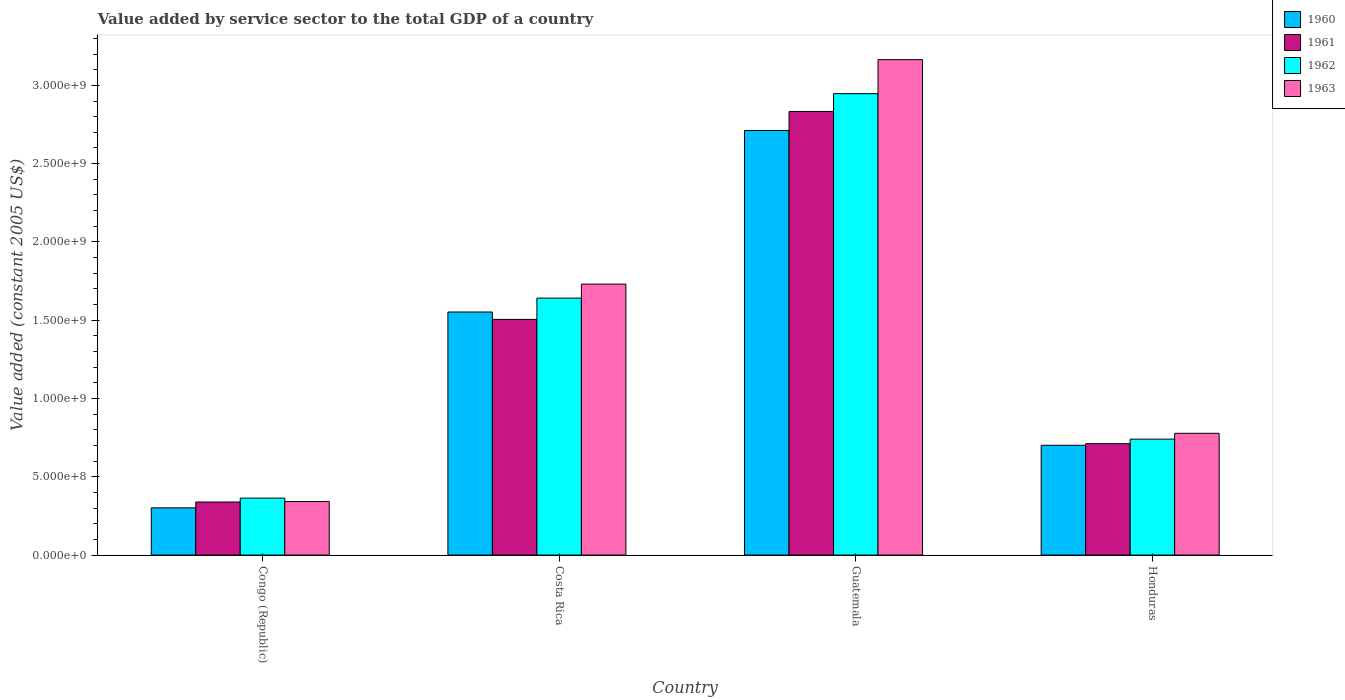Are the number of bars per tick equal to the number of legend labels?
Provide a succinct answer. Yes. Are the number of bars on each tick of the X-axis equal?
Keep it short and to the point. Yes. How many bars are there on the 4th tick from the left?
Give a very brief answer. 4. What is the value added by service sector in 1962 in Honduras?
Your answer should be compact. 7.41e+08. Across all countries, what is the maximum value added by service sector in 1962?
Keep it short and to the point. 2.95e+09. Across all countries, what is the minimum value added by service sector in 1961?
Your answer should be very brief. 3.39e+08. In which country was the value added by service sector in 1961 maximum?
Keep it short and to the point. Guatemala. In which country was the value added by service sector in 1963 minimum?
Keep it short and to the point. Congo (Republic). What is the total value added by service sector in 1963 in the graph?
Your answer should be compact. 6.01e+09. What is the difference between the value added by service sector in 1960 in Congo (Republic) and that in Honduras?
Your answer should be very brief. -4.00e+08. What is the difference between the value added by service sector in 1961 in Honduras and the value added by service sector in 1960 in Congo (Republic)?
Your answer should be compact. 4.10e+08. What is the average value added by service sector in 1961 per country?
Your response must be concise. 1.35e+09. What is the difference between the value added by service sector of/in 1961 and value added by service sector of/in 1962 in Costa Rica?
Make the answer very short. -1.36e+08. What is the ratio of the value added by service sector in 1960 in Congo (Republic) to that in Honduras?
Your answer should be compact. 0.43. What is the difference between the highest and the second highest value added by service sector in 1962?
Your response must be concise. -1.31e+09. What is the difference between the highest and the lowest value added by service sector in 1962?
Offer a terse response. 2.58e+09. In how many countries, is the value added by service sector in 1963 greater than the average value added by service sector in 1963 taken over all countries?
Ensure brevity in your answer.  2. Is the sum of the value added by service sector in 1960 in Costa Rica and Guatemala greater than the maximum value added by service sector in 1963 across all countries?
Give a very brief answer. Yes. Is it the case that in every country, the sum of the value added by service sector in 1960 and value added by service sector in 1963 is greater than the sum of value added by service sector in 1961 and value added by service sector in 1962?
Make the answer very short. No. How many bars are there?
Provide a short and direct response. 16. What is the difference between two consecutive major ticks on the Y-axis?
Your response must be concise. 5.00e+08. Are the values on the major ticks of Y-axis written in scientific E-notation?
Ensure brevity in your answer.  Yes. Does the graph contain grids?
Ensure brevity in your answer.  No. What is the title of the graph?
Your answer should be very brief. Value added by service sector to the total GDP of a country. What is the label or title of the X-axis?
Your response must be concise. Country. What is the label or title of the Y-axis?
Offer a terse response. Value added (constant 2005 US$). What is the Value added (constant 2005 US$) of 1960 in Congo (Republic)?
Provide a short and direct response. 3.02e+08. What is the Value added (constant 2005 US$) of 1961 in Congo (Republic)?
Ensure brevity in your answer.  3.39e+08. What is the Value added (constant 2005 US$) of 1962 in Congo (Republic)?
Your answer should be very brief. 3.64e+08. What is the Value added (constant 2005 US$) in 1963 in Congo (Republic)?
Your response must be concise. 3.42e+08. What is the Value added (constant 2005 US$) of 1960 in Costa Rica?
Provide a short and direct response. 1.55e+09. What is the Value added (constant 2005 US$) in 1961 in Costa Rica?
Offer a terse response. 1.51e+09. What is the Value added (constant 2005 US$) in 1962 in Costa Rica?
Keep it short and to the point. 1.64e+09. What is the Value added (constant 2005 US$) of 1963 in Costa Rica?
Keep it short and to the point. 1.73e+09. What is the Value added (constant 2005 US$) of 1960 in Guatemala?
Your response must be concise. 2.71e+09. What is the Value added (constant 2005 US$) in 1961 in Guatemala?
Your answer should be very brief. 2.83e+09. What is the Value added (constant 2005 US$) of 1962 in Guatemala?
Make the answer very short. 2.95e+09. What is the Value added (constant 2005 US$) of 1963 in Guatemala?
Ensure brevity in your answer.  3.16e+09. What is the Value added (constant 2005 US$) in 1960 in Honduras?
Your answer should be compact. 7.01e+08. What is the Value added (constant 2005 US$) of 1961 in Honduras?
Your response must be concise. 7.12e+08. What is the Value added (constant 2005 US$) in 1962 in Honduras?
Your response must be concise. 7.41e+08. What is the Value added (constant 2005 US$) of 1963 in Honduras?
Offer a very short reply. 7.78e+08. Across all countries, what is the maximum Value added (constant 2005 US$) of 1960?
Your response must be concise. 2.71e+09. Across all countries, what is the maximum Value added (constant 2005 US$) of 1961?
Provide a succinct answer. 2.83e+09. Across all countries, what is the maximum Value added (constant 2005 US$) of 1962?
Your answer should be compact. 2.95e+09. Across all countries, what is the maximum Value added (constant 2005 US$) in 1963?
Your answer should be compact. 3.16e+09. Across all countries, what is the minimum Value added (constant 2005 US$) in 1960?
Keep it short and to the point. 3.02e+08. Across all countries, what is the minimum Value added (constant 2005 US$) in 1961?
Keep it short and to the point. 3.39e+08. Across all countries, what is the minimum Value added (constant 2005 US$) of 1962?
Provide a succinct answer. 3.64e+08. Across all countries, what is the minimum Value added (constant 2005 US$) in 1963?
Your answer should be compact. 3.42e+08. What is the total Value added (constant 2005 US$) of 1960 in the graph?
Offer a very short reply. 5.27e+09. What is the total Value added (constant 2005 US$) in 1961 in the graph?
Keep it short and to the point. 5.39e+09. What is the total Value added (constant 2005 US$) of 1962 in the graph?
Make the answer very short. 5.69e+09. What is the total Value added (constant 2005 US$) of 1963 in the graph?
Give a very brief answer. 6.01e+09. What is the difference between the Value added (constant 2005 US$) of 1960 in Congo (Republic) and that in Costa Rica?
Your answer should be very brief. -1.25e+09. What is the difference between the Value added (constant 2005 US$) in 1961 in Congo (Republic) and that in Costa Rica?
Keep it short and to the point. -1.17e+09. What is the difference between the Value added (constant 2005 US$) of 1962 in Congo (Republic) and that in Costa Rica?
Ensure brevity in your answer.  -1.28e+09. What is the difference between the Value added (constant 2005 US$) in 1963 in Congo (Republic) and that in Costa Rica?
Keep it short and to the point. -1.39e+09. What is the difference between the Value added (constant 2005 US$) of 1960 in Congo (Republic) and that in Guatemala?
Offer a terse response. -2.41e+09. What is the difference between the Value added (constant 2005 US$) of 1961 in Congo (Republic) and that in Guatemala?
Give a very brief answer. -2.49e+09. What is the difference between the Value added (constant 2005 US$) of 1962 in Congo (Republic) and that in Guatemala?
Offer a very short reply. -2.58e+09. What is the difference between the Value added (constant 2005 US$) of 1963 in Congo (Republic) and that in Guatemala?
Make the answer very short. -2.82e+09. What is the difference between the Value added (constant 2005 US$) in 1960 in Congo (Republic) and that in Honduras?
Keep it short and to the point. -4.00e+08. What is the difference between the Value added (constant 2005 US$) in 1961 in Congo (Republic) and that in Honduras?
Make the answer very short. -3.73e+08. What is the difference between the Value added (constant 2005 US$) of 1962 in Congo (Republic) and that in Honduras?
Offer a terse response. -3.77e+08. What is the difference between the Value added (constant 2005 US$) of 1963 in Congo (Republic) and that in Honduras?
Give a very brief answer. -4.36e+08. What is the difference between the Value added (constant 2005 US$) of 1960 in Costa Rica and that in Guatemala?
Give a very brief answer. -1.16e+09. What is the difference between the Value added (constant 2005 US$) of 1961 in Costa Rica and that in Guatemala?
Make the answer very short. -1.33e+09. What is the difference between the Value added (constant 2005 US$) of 1962 in Costa Rica and that in Guatemala?
Offer a terse response. -1.31e+09. What is the difference between the Value added (constant 2005 US$) in 1963 in Costa Rica and that in Guatemala?
Ensure brevity in your answer.  -1.43e+09. What is the difference between the Value added (constant 2005 US$) of 1960 in Costa Rica and that in Honduras?
Give a very brief answer. 8.51e+08. What is the difference between the Value added (constant 2005 US$) of 1961 in Costa Rica and that in Honduras?
Provide a succinct answer. 7.94e+08. What is the difference between the Value added (constant 2005 US$) of 1962 in Costa Rica and that in Honduras?
Your answer should be compact. 9.01e+08. What is the difference between the Value added (constant 2005 US$) in 1963 in Costa Rica and that in Honduras?
Offer a very short reply. 9.53e+08. What is the difference between the Value added (constant 2005 US$) of 1960 in Guatemala and that in Honduras?
Your answer should be very brief. 2.01e+09. What is the difference between the Value added (constant 2005 US$) in 1961 in Guatemala and that in Honduras?
Make the answer very short. 2.12e+09. What is the difference between the Value added (constant 2005 US$) of 1962 in Guatemala and that in Honduras?
Provide a succinct answer. 2.21e+09. What is the difference between the Value added (constant 2005 US$) of 1963 in Guatemala and that in Honduras?
Your answer should be very brief. 2.39e+09. What is the difference between the Value added (constant 2005 US$) of 1960 in Congo (Republic) and the Value added (constant 2005 US$) of 1961 in Costa Rica?
Your answer should be compact. -1.20e+09. What is the difference between the Value added (constant 2005 US$) in 1960 in Congo (Republic) and the Value added (constant 2005 US$) in 1962 in Costa Rica?
Your response must be concise. -1.34e+09. What is the difference between the Value added (constant 2005 US$) in 1960 in Congo (Republic) and the Value added (constant 2005 US$) in 1963 in Costa Rica?
Offer a terse response. -1.43e+09. What is the difference between the Value added (constant 2005 US$) in 1961 in Congo (Republic) and the Value added (constant 2005 US$) in 1962 in Costa Rica?
Give a very brief answer. -1.30e+09. What is the difference between the Value added (constant 2005 US$) of 1961 in Congo (Republic) and the Value added (constant 2005 US$) of 1963 in Costa Rica?
Give a very brief answer. -1.39e+09. What is the difference between the Value added (constant 2005 US$) in 1962 in Congo (Republic) and the Value added (constant 2005 US$) in 1963 in Costa Rica?
Your response must be concise. -1.37e+09. What is the difference between the Value added (constant 2005 US$) of 1960 in Congo (Republic) and the Value added (constant 2005 US$) of 1961 in Guatemala?
Offer a terse response. -2.53e+09. What is the difference between the Value added (constant 2005 US$) in 1960 in Congo (Republic) and the Value added (constant 2005 US$) in 1962 in Guatemala?
Your answer should be compact. -2.65e+09. What is the difference between the Value added (constant 2005 US$) in 1960 in Congo (Republic) and the Value added (constant 2005 US$) in 1963 in Guatemala?
Your response must be concise. -2.86e+09. What is the difference between the Value added (constant 2005 US$) of 1961 in Congo (Republic) and the Value added (constant 2005 US$) of 1962 in Guatemala?
Offer a terse response. -2.61e+09. What is the difference between the Value added (constant 2005 US$) of 1961 in Congo (Republic) and the Value added (constant 2005 US$) of 1963 in Guatemala?
Ensure brevity in your answer.  -2.83e+09. What is the difference between the Value added (constant 2005 US$) in 1962 in Congo (Republic) and the Value added (constant 2005 US$) in 1963 in Guatemala?
Provide a succinct answer. -2.80e+09. What is the difference between the Value added (constant 2005 US$) of 1960 in Congo (Republic) and the Value added (constant 2005 US$) of 1961 in Honduras?
Provide a succinct answer. -4.10e+08. What is the difference between the Value added (constant 2005 US$) in 1960 in Congo (Republic) and the Value added (constant 2005 US$) in 1962 in Honduras?
Offer a very short reply. -4.39e+08. What is the difference between the Value added (constant 2005 US$) of 1960 in Congo (Republic) and the Value added (constant 2005 US$) of 1963 in Honduras?
Give a very brief answer. -4.76e+08. What is the difference between the Value added (constant 2005 US$) in 1961 in Congo (Republic) and the Value added (constant 2005 US$) in 1962 in Honduras?
Offer a very short reply. -4.02e+08. What is the difference between the Value added (constant 2005 US$) in 1961 in Congo (Republic) and the Value added (constant 2005 US$) in 1963 in Honduras?
Your answer should be compact. -4.39e+08. What is the difference between the Value added (constant 2005 US$) in 1962 in Congo (Republic) and the Value added (constant 2005 US$) in 1963 in Honduras?
Provide a succinct answer. -4.14e+08. What is the difference between the Value added (constant 2005 US$) in 1960 in Costa Rica and the Value added (constant 2005 US$) in 1961 in Guatemala?
Your answer should be compact. -1.28e+09. What is the difference between the Value added (constant 2005 US$) in 1960 in Costa Rica and the Value added (constant 2005 US$) in 1962 in Guatemala?
Provide a succinct answer. -1.39e+09. What is the difference between the Value added (constant 2005 US$) in 1960 in Costa Rica and the Value added (constant 2005 US$) in 1963 in Guatemala?
Keep it short and to the point. -1.61e+09. What is the difference between the Value added (constant 2005 US$) in 1961 in Costa Rica and the Value added (constant 2005 US$) in 1962 in Guatemala?
Provide a succinct answer. -1.44e+09. What is the difference between the Value added (constant 2005 US$) of 1961 in Costa Rica and the Value added (constant 2005 US$) of 1963 in Guatemala?
Offer a very short reply. -1.66e+09. What is the difference between the Value added (constant 2005 US$) in 1962 in Costa Rica and the Value added (constant 2005 US$) in 1963 in Guatemala?
Make the answer very short. -1.52e+09. What is the difference between the Value added (constant 2005 US$) in 1960 in Costa Rica and the Value added (constant 2005 US$) in 1961 in Honduras?
Offer a terse response. 8.41e+08. What is the difference between the Value added (constant 2005 US$) of 1960 in Costa Rica and the Value added (constant 2005 US$) of 1962 in Honduras?
Give a very brief answer. 8.12e+08. What is the difference between the Value added (constant 2005 US$) in 1960 in Costa Rica and the Value added (constant 2005 US$) in 1963 in Honduras?
Your answer should be compact. 7.75e+08. What is the difference between the Value added (constant 2005 US$) of 1961 in Costa Rica and the Value added (constant 2005 US$) of 1962 in Honduras?
Your response must be concise. 7.65e+08. What is the difference between the Value added (constant 2005 US$) in 1961 in Costa Rica and the Value added (constant 2005 US$) in 1963 in Honduras?
Keep it short and to the point. 7.28e+08. What is the difference between the Value added (constant 2005 US$) of 1962 in Costa Rica and the Value added (constant 2005 US$) of 1963 in Honduras?
Give a very brief answer. 8.63e+08. What is the difference between the Value added (constant 2005 US$) of 1960 in Guatemala and the Value added (constant 2005 US$) of 1961 in Honduras?
Make the answer very short. 2.00e+09. What is the difference between the Value added (constant 2005 US$) of 1960 in Guatemala and the Value added (constant 2005 US$) of 1962 in Honduras?
Provide a succinct answer. 1.97e+09. What is the difference between the Value added (constant 2005 US$) in 1960 in Guatemala and the Value added (constant 2005 US$) in 1963 in Honduras?
Make the answer very short. 1.93e+09. What is the difference between the Value added (constant 2005 US$) in 1961 in Guatemala and the Value added (constant 2005 US$) in 1962 in Honduras?
Your response must be concise. 2.09e+09. What is the difference between the Value added (constant 2005 US$) of 1961 in Guatemala and the Value added (constant 2005 US$) of 1963 in Honduras?
Provide a short and direct response. 2.06e+09. What is the difference between the Value added (constant 2005 US$) of 1962 in Guatemala and the Value added (constant 2005 US$) of 1963 in Honduras?
Your response must be concise. 2.17e+09. What is the average Value added (constant 2005 US$) in 1960 per country?
Provide a short and direct response. 1.32e+09. What is the average Value added (constant 2005 US$) in 1961 per country?
Your answer should be compact. 1.35e+09. What is the average Value added (constant 2005 US$) of 1962 per country?
Offer a very short reply. 1.42e+09. What is the average Value added (constant 2005 US$) in 1963 per country?
Make the answer very short. 1.50e+09. What is the difference between the Value added (constant 2005 US$) in 1960 and Value added (constant 2005 US$) in 1961 in Congo (Republic)?
Provide a short and direct response. -3.74e+07. What is the difference between the Value added (constant 2005 US$) of 1960 and Value added (constant 2005 US$) of 1962 in Congo (Republic)?
Offer a very short reply. -6.23e+07. What is the difference between the Value added (constant 2005 US$) of 1960 and Value added (constant 2005 US$) of 1963 in Congo (Republic)?
Provide a short and direct response. -4.05e+07. What is the difference between the Value added (constant 2005 US$) in 1961 and Value added (constant 2005 US$) in 1962 in Congo (Republic)?
Make the answer very short. -2.49e+07. What is the difference between the Value added (constant 2005 US$) of 1961 and Value added (constant 2005 US$) of 1963 in Congo (Republic)?
Provide a succinct answer. -3.09e+06. What is the difference between the Value added (constant 2005 US$) of 1962 and Value added (constant 2005 US$) of 1963 in Congo (Republic)?
Provide a succinct answer. 2.18e+07. What is the difference between the Value added (constant 2005 US$) in 1960 and Value added (constant 2005 US$) in 1961 in Costa Rica?
Provide a short and direct response. 4.72e+07. What is the difference between the Value added (constant 2005 US$) of 1960 and Value added (constant 2005 US$) of 1962 in Costa Rica?
Your answer should be very brief. -8.87e+07. What is the difference between the Value added (constant 2005 US$) of 1960 and Value added (constant 2005 US$) of 1963 in Costa Rica?
Provide a short and direct response. -1.78e+08. What is the difference between the Value added (constant 2005 US$) in 1961 and Value added (constant 2005 US$) in 1962 in Costa Rica?
Give a very brief answer. -1.36e+08. What is the difference between the Value added (constant 2005 US$) of 1961 and Value added (constant 2005 US$) of 1963 in Costa Rica?
Provide a succinct answer. -2.25e+08. What is the difference between the Value added (constant 2005 US$) in 1962 and Value added (constant 2005 US$) in 1963 in Costa Rica?
Provide a succinct answer. -8.94e+07. What is the difference between the Value added (constant 2005 US$) in 1960 and Value added (constant 2005 US$) in 1961 in Guatemala?
Your answer should be very brief. -1.22e+08. What is the difference between the Value added (constant 2005 US$) of 1960 and Value added (constant 2005 US$) of 1962 in Guatemala?
Provide a short and direct response. -2.35e+08. What is the difference between the Value added (constant 2005 US$) of 1960 and Value added (constant 2005 US$) of 1963 in Guatemala?
Your response must be concise. -4.53e+08. What is the difference between the Value added (constant 2005 US$) of 1961 and Value added (constant 2005 US$) of 1962 in Guatemala?
Provide a succinct answer. -1.14e+08. What is the difference between the Value added (constant 2005 US$) in 1961 and Value added (constant 2005 US$) in 1963 in Guatemala?
Offer a very short reply. -3.31e+08. What is the difference between the Value added (constant 2005 US$) of 1962 and Value added (constant 2005 US$) of 1963 in Guatemala?
Ensure brevity in your answer.  -2.17e+08. What is the difference between the Value added (constant 2005 US$) of 1960 and Value added (constant 2005 US$) of 1961 in Honduras?
Ensure brevity in your answer.  -1.04e+07. What is the difference between the Value added (constant 2005 US$) of 1960 and Value added (constant 2005 US$) of 1962 in Honduras?
Make the answer very short. -3.93e+07. What is the difference between the Value added (constant 2005 US$) of 1960 and Value added (constant 2005 US$) of 1963 in Honduras?
Your answer should be very brief. -7.65e+07. What is the difference between the Value added (constant 2005 US$) of 1961 and Value added (constant 2005 US$) of 1962 in Honduras?
Keep it short and to the point. -2.89e+07. What is the difference between the Value added (constant 2005 US$) of 1961 and Value added (constant 2005 US$) of 1963 in Honduras?
Provide a succinct answer. -6.62e+07. What is the difference between the Value added (constant 2005 US$) in 1962 and Value added (constant 2005 US$) in 1963 in Honduras?
Your answer should be compact. -3.72e+07. What is the ratio of the Value added (constant 2005 US$) in 1960 in Congo (Republic) to that in Costa Rica?
Keep it short and to the point. 0.19. What is the ratio of the Value added (constant 2005 US$) of 1961 in Congo (Republic) to that in Costa Rica?
Give a very brief answer. 0.23. What is the ratio of the Value added (constant 2005 US$) in 1962 in Congo (Republic) to that in Costa Rica?
Keep it short and to the point. 0.22. What is the ratio of the Value added (constant 2005 US$) of 1963 in Congo (Republic) to that in Costa Rica?
Your answer should be compact. 0.2. What is the ratio of the Value added (constant 2005 US$) of 1960 in Congo (Republic) to that in Guatemala?
Your answer should be very brief. 0.11. What is the ratio of the Value added (constant 2005 US$) of 1961 in Congo (Republic) to that in Guatemala?
Offer a terse response. 0.12. What is the ratio of the Value added (constant 2005 US$) of 1962 in Congo (Republic) to that in Guatemala?
Offer a very short reply. 0.12. What is the ratio of the Value added (constant 2005 US$) in 1963 in Congo (Republic) to that in Guatemala?
Your response must be concise. 0.11. What is the ratio of the Value added (constant 2005 US$) in 1960 in Congo (Republic) to that in Honduras?
Offer a terse response. 0.43. What is the ratio of the Value added (constant 2005 US$) in 1961 in Congo (Republic) to that in Honduras?
Your answer should be compact. 0.48. What is the ratio of the Value added (constant 2005 US$) of 1962 in Congo (Republic) to that in Honduras?
Your answer should be very brief. 0.49. What is the ratio of the Value added (constant 2005 US$) in 1963 in Congo (Republic) to that in Honduras?
Offer a terse response. 0.44. What is the ratio of the Value added (constant 2005 US$) of 1960 in Costa Rica to that in Guatemala?
Your response must be concise. 0.57. What is the ratio of the Value added (constant 2005 US$) of 1961 in Costa Rica to that in Guatemala?
Provide a succinct answer. 0.53. What is the ratio of the Value added (constant 2005 US$) of 1962 in Costa Rica to that in Guatemala?
Your answer should be very brief. 0.56. What is the ratio of the Value added (constant 2005 US$) in 1963 in Costa Rica to that in Guatemala?
Ensure brevity in your answer.  0.55. What is the ratio of the Value added (constant 2005 US$) in 1960 in Costa Rica to that in Honduras?
Give a very brief answer. 2.21. What is the ratio of the Value added (constant 2005 US$) in 1961 in Costa Rica to that in Honduras?
Make the answer very short. 2.12. What is the ratio of the Value added (constant 2005 US$) in 1962 in Costa Rica to that in Honduras?
Provide a short and direct response. 2.22. What is the ratio of the Value added (constant 2005 US$) in 1963 in Costa Rica to that in Honduras?
Offer a very short reply. 2.23. What is the ratio of the Value added (constant 2005 US$) of 1960 in Guatemala to that in Honduras?
Provide a succinct answer. 3.87. What is the ratio of the Value added (constant 2005 US$) of 1961 in Guatemala to that in Honduras?
Ensure brevity in your answer.  3.98. What is the ratio of the Value added (constant 2005 US$) of 1962 in Guatemala to that in Honduras?
Ensure brevity in your answer.  3.98. What is the ratio of the Value added (constant 2005 US$) of 1963 in Guatemala to that in Honduras?
Give a very brief answer. 4.07. What is the difference between the highest and the second highest Value added (constant 2005 US$) of 1960?
Your answer should be very brief. 1.16e+09. What is the difference between the highest and the second highest Value added (constant 2005 US$) of 1961?
Give a very brief answer. 1.33e+09. What is the difference between the highest and the second highest Value added (constant 2005 US$) in 1962?
Give a very brief answer. 1.31e+09. What is the difference between the highest and the second highest Value added (constant 2005 US$) in 1963?
Keep it short and to the point. 1.43e+09. What is the difference between the highest and the lowest Value added (constant 2005 US$) in 1960?
Offer a terse response. 2.41e+09. What is the difference between the highest and the lowest Value added (constant 2005 US$) of 1961?
Ensure brevity in your answer.  2.49e+09. What is the difference between the highest and the lowest Value added (constant 2005 US$) of 1962?
Offer a very short reply. 2.58e+09. What is the difference between the highest and the lowest Value added (constant 2005 US$) in 1963?
Ensure brevity in your answer.  2.82e+09. 